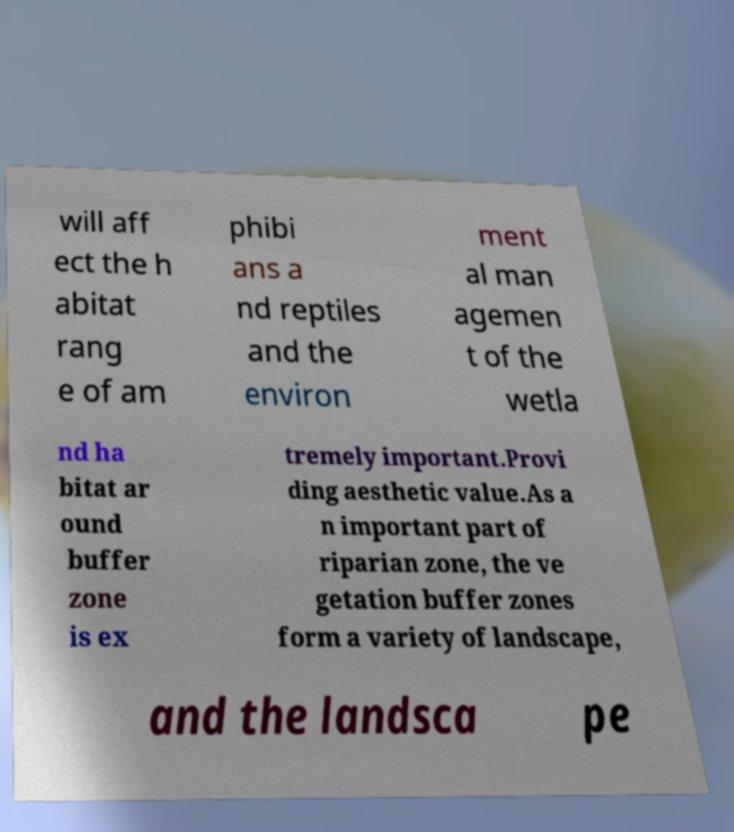There's text embedded in this image that I need extracted. Can you transcribe it verbatim? will aff ect the h abitat rang e of am phibi ans a nd reptiles and the environ ment al man agemen t of the wetla nd ha bitat ar ound buffer zone is ex tremely important.Provi ding aesthetic value.As a n important part of riparian zone, the ve getation buffer zones form a variety of landscape, and the landsca pe 